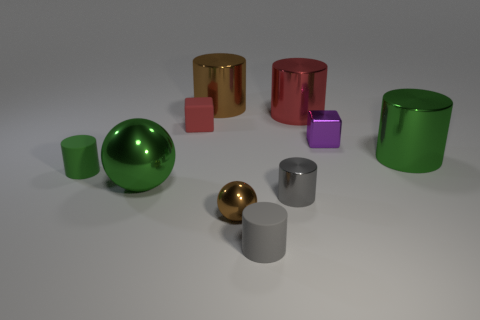Are there any large things behind the shiny cube?
Your answer should be compact. Yes. Do the red thing that is to the right of the brown cylinder and the brown shiny object that is behind the green metallic cylinder have the same shape?
Your answer should be compact. Yes. There is a red object that is the same shape as the tiny green thing; what material is it?
Offer a terse response. Metal. What number of spheres are red matte things or red things?
Provide a succinct answer. 0. What number of other objects have the same material as the tiny red thing?
Your answer should be very brief. 2. Do the green cylinder that is to the left of the tiny purple metal block and the gray cylinder in front of the tiny brown metal object have the same material?
Provide a succinct answer. Yes. There is a red thing on the left side of the tiny matte object to the right of the matte block; what number of gray rubber cylinders are left of it?
Give a very brief answer. 0. Does the rubber cylinder to the right of the tiny ball have the same color as the shiny cylinder in front of the big ball?
Provide a succinct answer. Yes. Is there any other thing that is the same color as the big ball?
Keep it short and to the point. Yes. What color is the rubber object that is behind the green thing on the left side of the big green sphere?
Ensure brevity in your answer.  Red. 